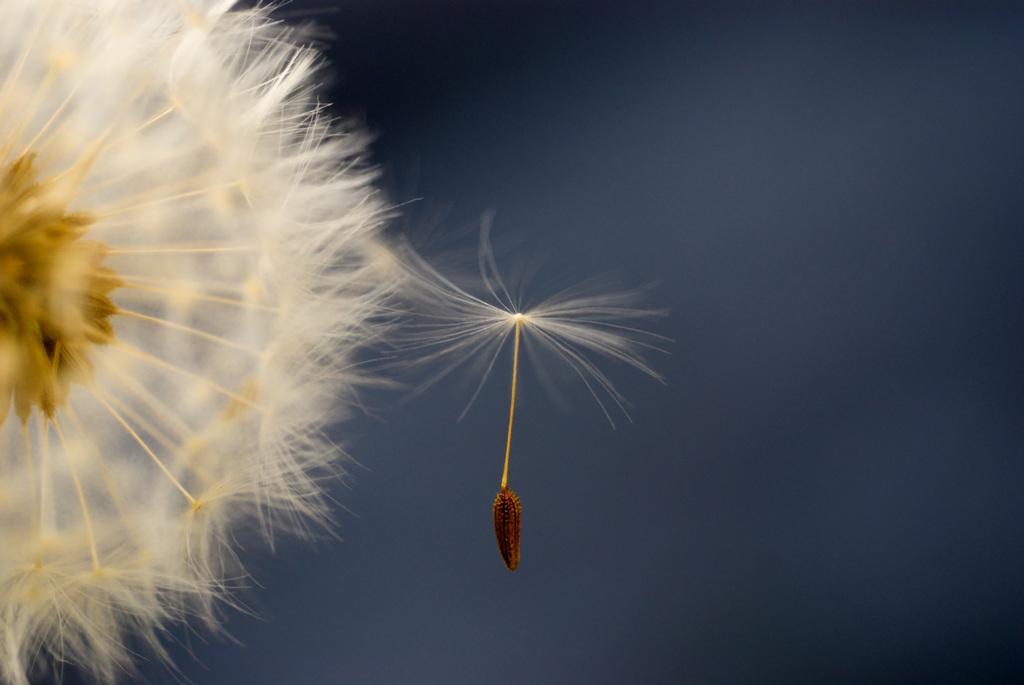Please provide a concise description of this image. In this picture we can see a dandelion flower in the front, there is a blurry background. 